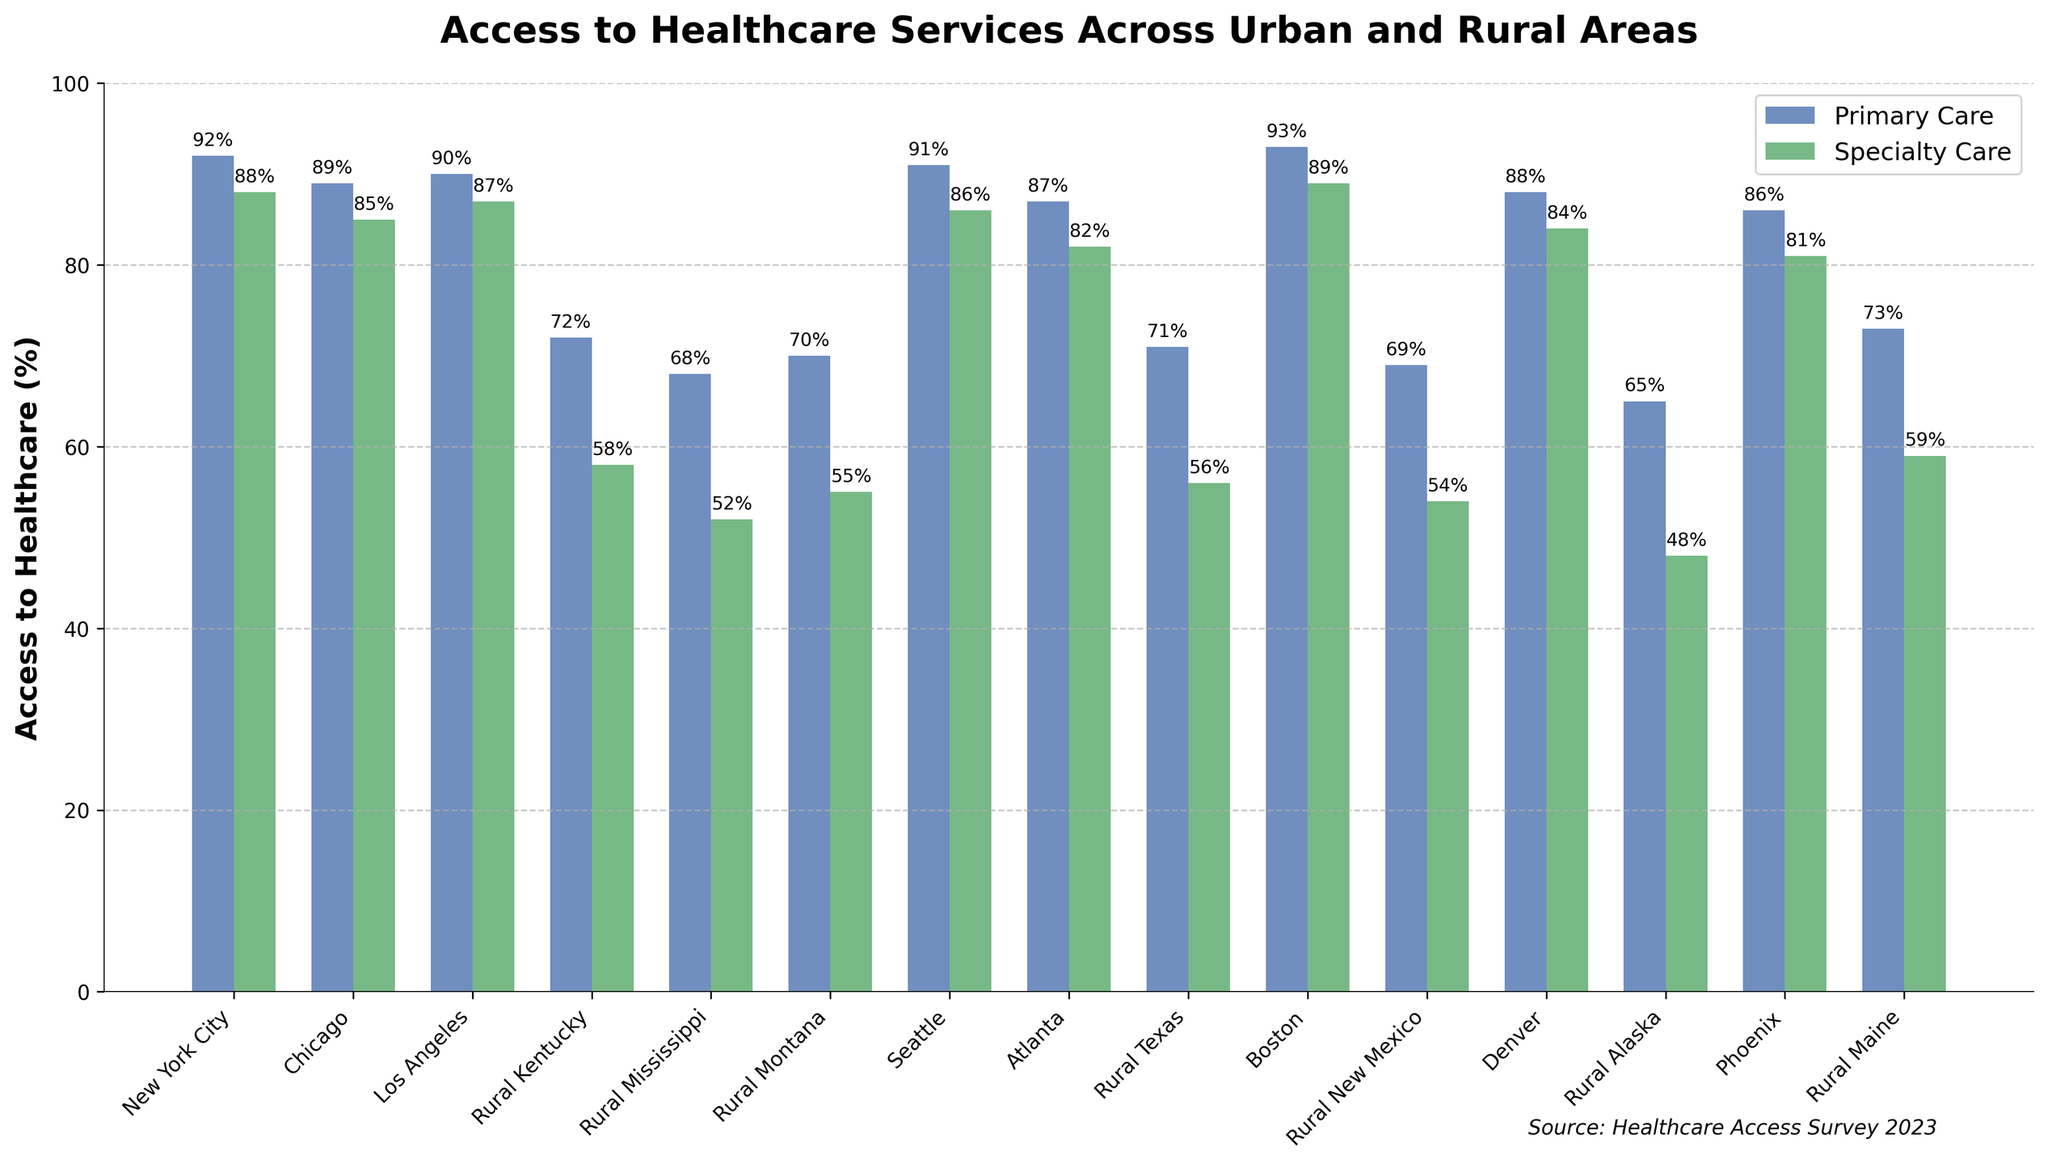What's the difference in access to primary care between Boston and Rural Alaska? Access to primary care in Boston is 93%, while in Rural Alaska it's 65%. To find the difference, subtract the smaller percentage from the larger one: 93% - 65% = 28%.
Answer: 28% Which area has the highest access to specialty care, and what is the percentage? By looking at the heights of the bars for specialty care, Boston has the highest access at 89%.
Answer: Boston, 89% How does the access to primary care in Rural Texas compare to Rural Kentucky? The access to primary care in Rural Texas is 71%, while in Rural Kentucky it's 72%. Rural Kentucky's bar is slightly higher than Rural Texas.
Answer: Rural Kentucky is 1% higher What is the average access to primary care across the three rural areas with the highest percentages? The rural areas with the highest access to primary care are Rural Maine (73%), Rural Kentucky (72%), and Rural Texas (71%). The average is (73% + 72% + 71%) / 3 = 72%.
Answer: 72% Which urban area has the lowest access to specialty care, and what is the percentage? By comparing the heights of the specialty care bars for urban areas, Phoenix has the lowest access to specialty care at 81%.
Answer: Phoenix, 81% In which area is the gap between access to primary care and specialty care the largest, and what is the gap? The largest difference between primary and specialty care is in Rural Alaska, where access to primary care is 65% and to specialty care is 48%. The gap is 65% - 48% = 17%.
Answer: Rural Alaska, 17% What is the total percentage of access to primary care for Los Angeles, Chicago, and Seattle combined? The access to primary care for Los Angeles is 90%, Chicago is 89%, and Seattle is 91%. The total is 90% + 89% + 91% = 270%.
Answer: 270% How does the access to specialty care in New York City compare to Atlanta? The access to specialty care in New York City is 88%, while in Atlanta it is 82%. New York City's bar is higher.
Answer: New York City is 6% higher Which urban area has the bar with the second highest access to primary care and what is the percentage? By comparing the heights of the primary care bars for urban areas, Boston has the highest at 93%, and New York City has the second highest at 92%.
Answer: New York City, 92% What is the combined access to primary care and specialty care in Rural Mississippi? In Rural Mississippi, the access to primary care is 68% and to specialty care is 52%. The combined access is 68% + 52% = 120%.
Answer: 120% 